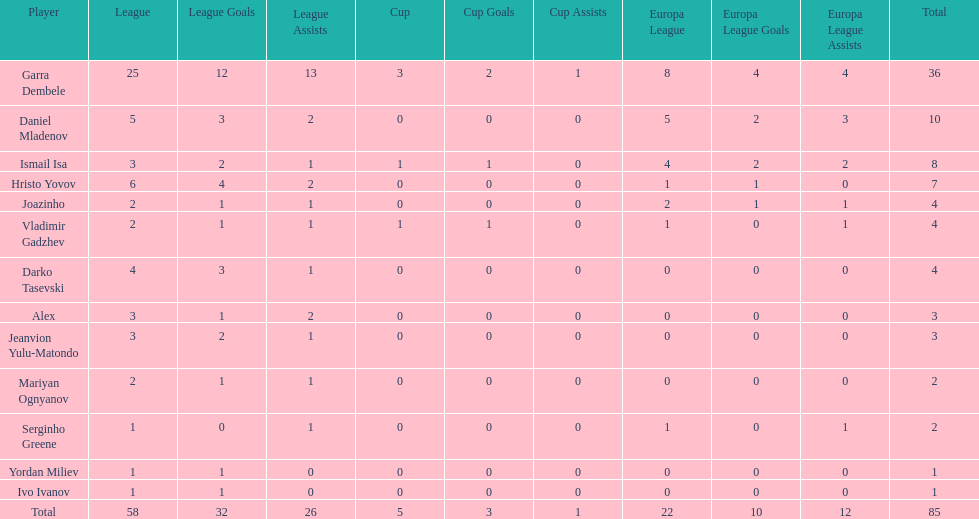How many players did not score a goal in cup play? 10. 